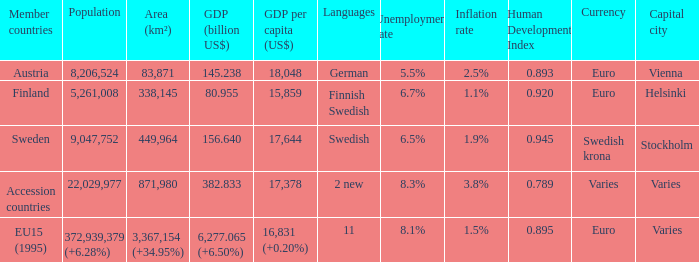Name the member countries for finnish swedish Finland. 